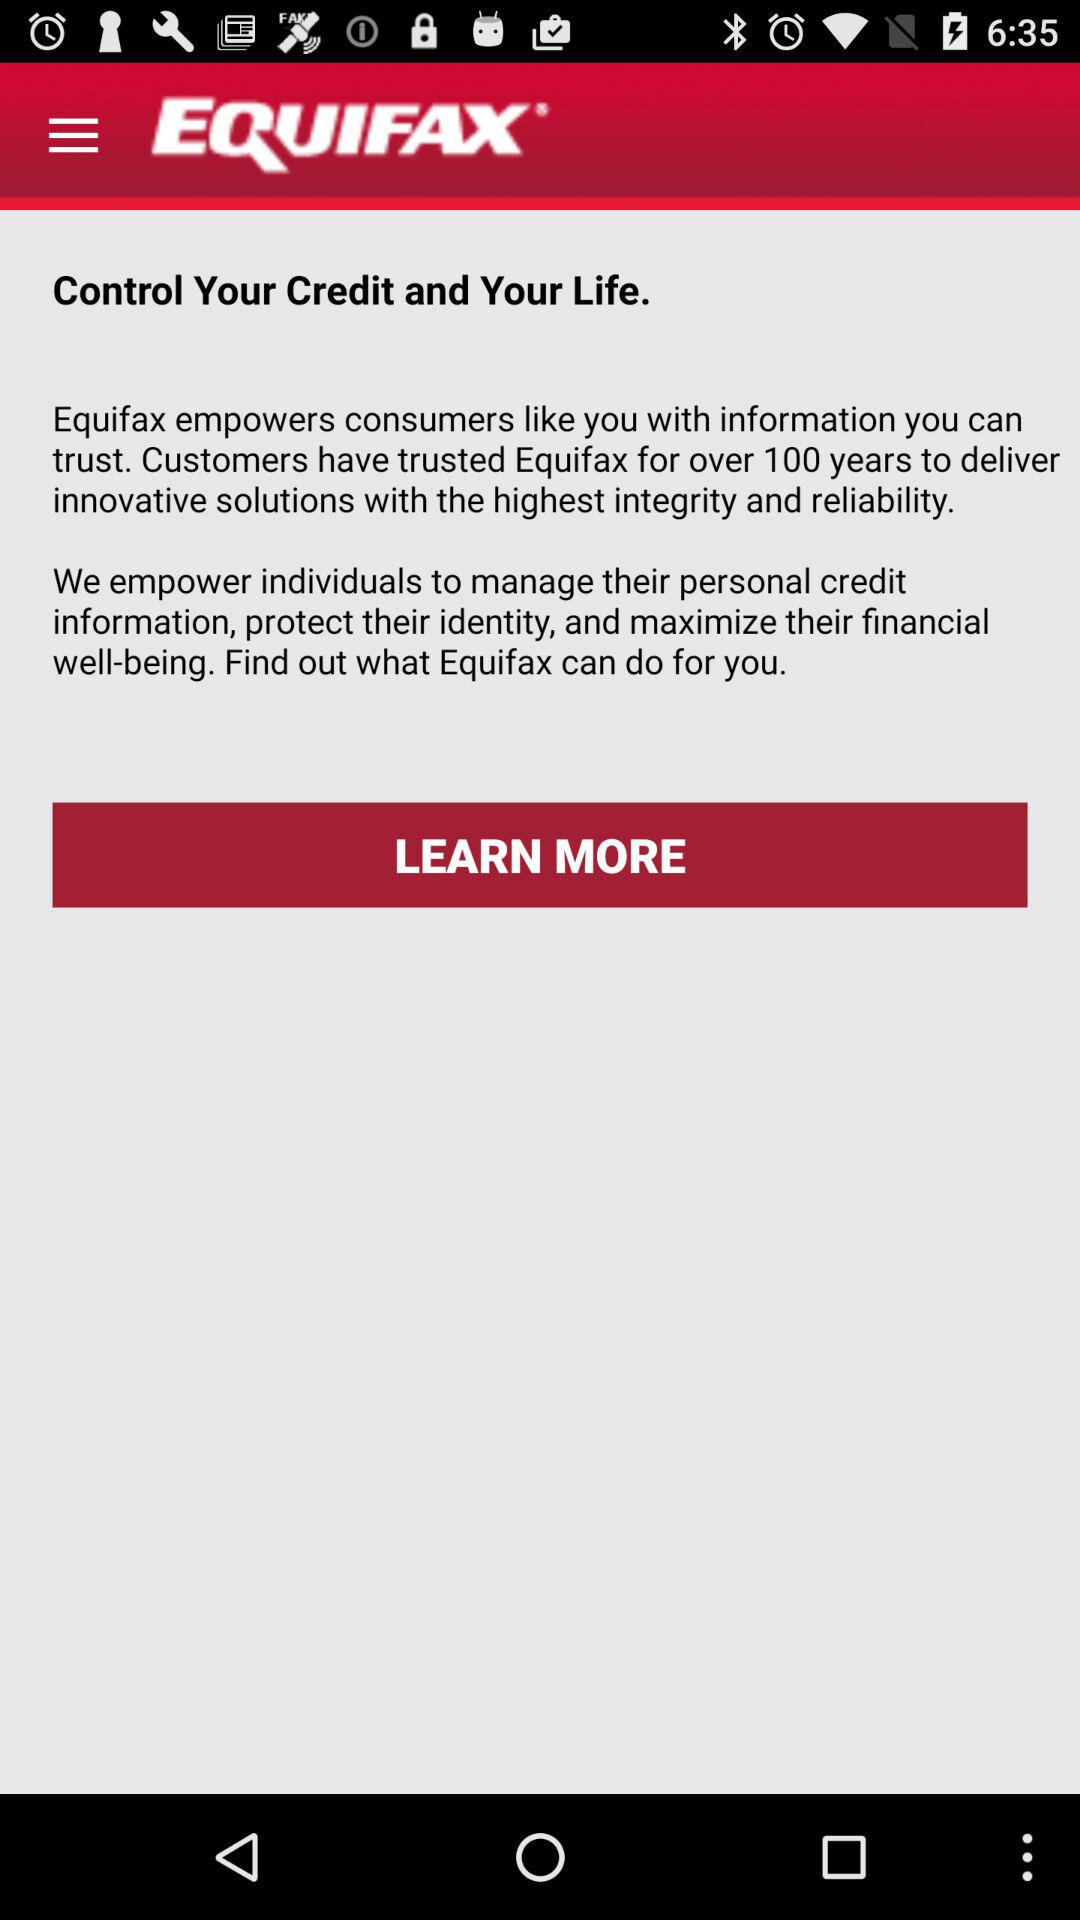What is the Equifax?
When the provided information is insufficient, respond with <no answer>. <no answer> 